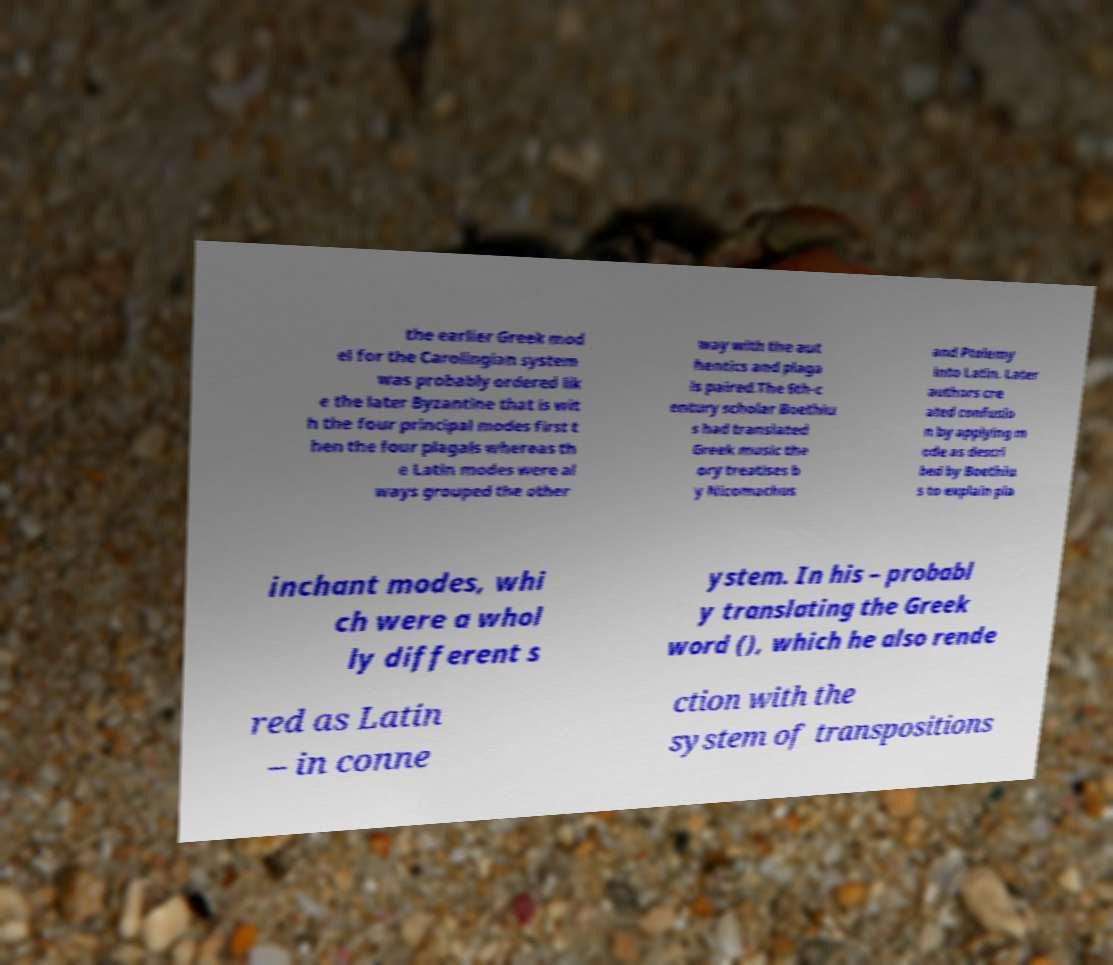I need the written content from this picture converted into text. Can you do that? the earlier Greek mod el for the Carolingian system was probably ordered lik e the later Byzantine that is wit h the four principal modes first t hen the four plagals whereas th e Latin modes were al ways grouped the other way with the aut hentics and plaga ls paired.The 6th-c entury scholar Boethiu s had translated Greek music the ory treatises b y Nicomachus and Ptolemy into Latin. Later authors cre ated confusio n by applying m ode as descri bed by Boethiu s to explain pla inchant modes, whi ch were a whol ly different s ystem. In his – probabl y translating the Greek word (), which he also rende red as Latin – in conne ction with the system of transpositions 